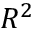Convert formula to latex. <formula><loc_0><loc_0><loc_500><loc_500>R ^ { 2 }</formula> 